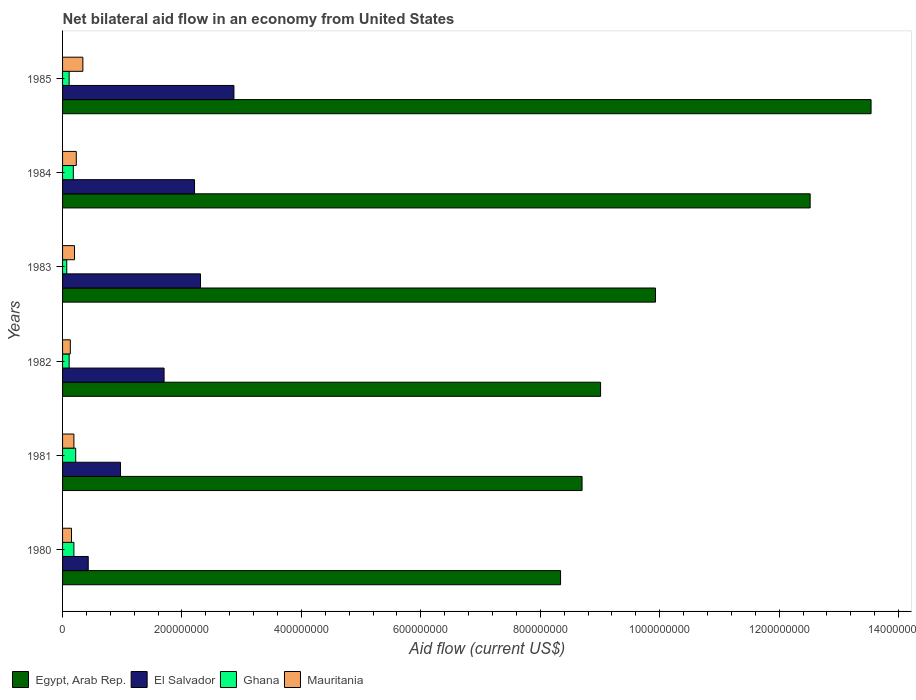Are the number of bars per tick equal to the number of legend labels?
Provide a succinct answer. Yes. Are the number of bars on each tick of the Y-axis equal?
Make the answer very short. Yes. How many bars are there on the 6th tick from the top?
Ensure brevity in your answer.  4. What is the label of the 1st group of bars from the top?
Your answer should be compact. 1985. In how many cases, is the number of bars for a given year not equal to the number of legend labels?
Your answer should be compact. 0. What is the net bilateral aid flow in Egypt, Arab Rep. in 1984?
Offer a very short reply. 1.25e+09. Across all years, what is the maximum net bilateral aid flow in Ghana?
Offer a very short reply. 2.20e+07. Across all years, what is the minimum net bilateral aid flow in Mauritania?
Keep it short and to the point. 1.30e+07. What is the total net bilateral aid flow in Mauritania in the graph?
Provide a succinct answer. 1.24e+08. What is the difference between the net bilateral aid flow in Egypt, Arab Rep. in 1982 and that in 1985?
Offer a terse response. -4.53e+08. What is the difference between the net bilateral aid flow in Egypt, Arab Rep. in 1985 and the net bilateral aid flow in Ghana in 1984?
Keep it short and to the point. 1.34e+09. What is the average net bilateral aid flow in El Salvador per year?
Make the answer very short. 1.75e+08. In the year 1985, what is the difference between the net bilateral aid flow in El Salvador and net bilateral aid flow in Egypt, Arab Rep.?
Keep it short and to the point. -1.07e+09. What is the ratio of the net bilateral aid flow in Egypt, Arab Rep. in 1980 to that in 1985?
Offer a terse response. 0.62. Is the net bilateral aid flow in Mauritania in 1980 less than that in 1981?
Ensure brevity in your answer.  Yes. Is the difference between the net bilateral aid flow in El Salvador in 1981 and 1983 greater than the difference between the net bilateral aid flow in Egypt, Arab Rep. in 1981 and 1983?
Your answer should be very brief. No. What is the difference between the highest and the second highest net bilateral aid flow in Egypt, Arab Rep.?
Provide a short and direct response. 1.02e+08. What is the difference between the highest and the lowest net bilateral aid flow in Egypt, Arab Rep.?
Ensure brevity in your answer.  5.20e+08. Is the sum of the net bilateral aid flow in Egypt, Arab Rep. in 1984 and 1985 greater than the maximum net bilateral aid flow in Ghana across all years?
Keep it short and to the point. Yes. What does the 1st bar from the top in 1984 represents?
Provide a short and direct response. Mauritania. What does the 1st bar from the bottom in 1985 represents?
Give a very brief answer. Egypt, Arab Rep. What is the difference between two consecutive major ticks on the X-axis?
Your answer should be very brief. 2.00e+08. Are the values on the major ticks of X-axis written in scientific E-notation?
Offer a very short reply. No. Does the graph contain any zero values?
Give a very brief answer. No. Where does the legend appear in the graph?
Your answer should be very brief. Bottom left. How many legend labels are there?
Offer a terse response. 4. What is the title of the graph?
Provide a succinct answer. Net bilateral aid flow in an economy from United States. Does "Italy" appear as one of the legend labels in the graph?
Offer a terse response. No. What is the Aid flow (current US$) of Egypt, Arab Rep. in 1980?
Provide a succinct answer. 8.34e+08. What is the Aid flow (current US$) of El Salvador in 1980?
Make the answer very short. 4.30e+07. What is the Aid flow (current US$) in Ghana in 1980?
Provide a succinct answer. 1.90e+07. What is the Aid flow (current US$) of Mauritania in 1980?
Keep it short and to the point. 1.50e+07. What is the Aid flow (current US$) in Egypt, Arab Rep. in 1981?
Give a very brief answer. 8.70e+08. What is the Aid flow (current US$) of El Salvador in 1981?
Ensure brevity in your answer.  9.70e+07. What is the Aid flow (current US$) in Ghana in 1981?
Make the answer very short. 2.20e+07. What is the Aid flow (current US$) of Mauritania in 1981?
Your answer should be very brief. 1.90e+07. What is the Aid flow (current US$) in Egypt, Arab Rep. in 1982?
Provide a short and direct response. 9.01e+08. What is the Aid flow (current US$) of El Salvador in 1982?
Make the answer very short. 1.70e+08. What is the Aid flow (current US$) in Ghana in 1982?
Your response must be concise. 1.10e+07. What is the Aid flow (current US$) of Mauritania in 1982?
Make the answer very short. 1.30e+07. What is the Aid flow (current US$) in Egypt, Arab Rep. in 1983?
Make the answer very short. 9.93e+08. What is the Aid flow (current US$) in El Salvador in 1983?
Ensure brevity in your answer.  2.31e+08. What is the Aid flow (current US$) in Mauritania in 1983?
Make the answer very short. 2.00e+07. What is the Aid flow (current US$) in Egypt, Arab Rep. in 1984?
Offer a terse response. 1.25e+09. What is the Aid flow (current US$) of El Salvador in 1984?
Offer a terse response. 2.21e+08. What is the Aid flow (current US$) of Ghana in 1984?
Ensure brevity in your answer.  1.80e+07. What is the Aid flow (current US$) of Mauritania in 1984?
Your answer should be very brief. 2.30e+07. What is the Aid flow (current US$) of Egypt, Arab Rep. in 1985?
Your answer should be very brief. 1.35e+09. What is the Aid flow (current US$) of El Salvador in 1985?
Keep it short and to the point. 2.87e+08. What is the Aid flow (current US$) in Ghana in 1985?
Offer a very short reply. 1.10e+07. What is the Aid flow (current US$) in Mauritania in 1985?
Your answer should be very brief. 3.40e+07. Across all years, what is the maximum Aid flow (current US$) of Egypt, Arab Rep.?
Give a very brief answer. 1.35e+09. Across all years, what is the maximum Aid flow (current US$) in El Salvador?
Offer a terse response. 2.87e+08. Across all years, what is the maximum Aid flow (current US$) of Ghana?
Make the answer very short. 2.20e+07. Across all years, what is the maximum Aid flow (current US$) in Mauritania?
Give a very brief answer. 3.40e+07. Across all years, what is the minimum Aid flow (current US$) of Egypt, Arab Rep.?
Your answer should be compact. 8.34e+08. Across all years, what is the minimum Aid flow (current US$) in El Salvador?
Your response must be concise. 4.30e+07. Across all years, what is the minimum Aid flow (current US$) in Mauritania?
Ensure brevity in your answer.  1.30e+07. What is the total Aid flow (current US$) in Egypt, Arab Rep. in the graph?
Keep it short and to the point. 6.20e+09. What is the total Aid flow (current US$) of El Salvador in the graph?
Offer a terse response. 1.05e+09. What is the total Aid flow (current US$) of Ghana in the graph?
Offer a terse response. 8.80e+07. What is the total Aid flow (current US$) in Mauritania in the graph?
Provide a succinct answer. 1.24e+08. What is the difference between the Aid flow (current US$) in Egypt, Arab Rep. in 1980 and that in 1981?
Offer a very short reply. -3.60e+07. What is the difference between the Aid flow (current US$) of El Salvador in 1980 and that in 1981?
Provide a succinct answer. -5.40e+07. What is the difference between the Aid flow (current US$) in Ghana in 1980 and that in 1981?
Provide a short and direct response. -3.00e+06. What is the difference between the Aid flow (current US$) in Egypt, Arab Rep. in 1980 and that in 1982?
Provide a short and direct response. -6.70e+07. What is the difference between the Aid flow (current US$) in El Salvador in 1980 and that in 1982?
Your answer should be compact. -1.27e+08. What is the difference between the Aid flow (current US$) in Ghana in 1980 and that in 1982?
Keep it short and to the point. 8.00e+06. What is the difference between the Aid flow (current US$) of Mauritania in 1980 and that in 1982?
Keep it short and to the point. 2.00e+06. What is the difference between the Aid flow (current US$) of Egypt, Arab Rep. in 1980 and that in 1983?
Your answer should be compact. -1.59e+08. What is the difference between the Aid flow (current US$) of El Salvador in 1980 and that in 1983?
Ensure brevity in your answer.  -1.88e+08. What is the difference between the Aid flow (current US$) of Ghana in 1980 and that in 1983?
Keep it short and to the point. 1.20e+07. What is the difference between the Aid flow (current US$) of Mauritania in 1980 and that in 1983?
Offer a terse response. -5.00e+06. What is the difference between the Aid flow (current US$) in Egypt, Arab Rep. in 1980 and that in 1984?
Give a very brief answer. -4.18e+08. What is the difference between the Aid flow (current US$) in El Salvador in 1980 and that in 1984?
Provide a succinct answer. -1.78e+08. What is the difference between the Aid flow (current US$) in Ghana in 1980 and that in 1984?
Your answer should be very brief. 1.00e+06. What is the difference between the Aid flow (current US$) of Mauritania in 1980 and that in 1984?
Provide a succinct answer. -8.00e+06. What is the difference between the Aid flow (current US$) in Egypt, Arab Rep. in 1980 and that in 1985?
Ensure brevity in your answer.  -5.20e+08. What is the difference between the Aid flow (current US$) of El Salvador in 1980 and that in 1985?
Offer a terse response. -2.44e+08. What is the difference between the Aid flow (current US$) of Mauritania in 1980 and that in 1985?
Your answer should be compact. -1.90e+07. What is the difference between the Aid flow (current US$) of Egypt, Arab Rep. in 1981 and that in 1982?
Give a very brief answer. -3.10e+07. What is the difference between the Aid flow (current US$) in El Salvador in 1981 and that in 1982?
Ensure brevity in your answer.  -7.30e+07. What is the difference between the Aid flow (current US$) in Ghana in 1981 and that in 1982?
Ensure brevity in your answer.  1.10e+07. What is the difference between the Aid flow (current US$) of Mauritania in 1981 and that in 1982?
Your answer should be very brief. 6.00e+06. What is the difference between the Aid flow (current US$) of Egypt, Arab Rep. in 1981 and that in 1983?
Give a very brief answer. -1.23e+08. What is the difference between the Aid flow (current US$) in El Salvador in 1981 and that in 1983?
Provide a succinct answer. -1.34e+08. What is the difference between the Aid flow (current US$) of Ghana in 1981 and that in 1983?
Make the answer very short. 1.50e+07. What is the difference between the Aid flow (current US$) in Egypt, Arab Rep. in 1981 and that in 1984?
Provide a short and direct response. -3.82e+08. What is the difference between the Aid flow (current US$) of El Salvador in 1981 and that in 1984?
Ensure brevity in your answer.  -1.24e+08. What is the difference between the Aid flow (current US$) of Ghana in 1981 and that in 1984?
Ensure brevity in your answer.  4.00e+06. What is the difference between the Aid flow (current US$) of Mauritania in 1981 and that in 1984?
Offer a very short reply. -4.00e+06. What is the difference between the Aid flow (current US$) in Egypt, Arab Rep. in 1981 and that in 1985?
Offer a terse response. -4.84e+08. What is the difference between the Aid flow (current US$) of El Salvador in 1981 and that in 1985?
Offer a very short reply. -1.90e+08. What is the difference between the Aid flow (current US$) of Ghana in 1981 and that in 1985?
Your answer should be compact. 1.10e+07. What is the difference between the Aid flow (current US$) of Mauritania in 1981 and that in 1985?
Your response must be concise. -1.50e+07. What is the difference between the Aid flow (current US$) of Egypt, Arab Rep. in 1982 and that in 1983?
Keep it short and to the point. -9.20e+07. What is the difference between the Aid flow (current US$) of El Salvador in 1982 and that in 1983?
Offer a very short reply. -6.10e+07. What is the difference between the Aid flow (current US$) in Ghana in 1982 and that in 1983?
Your response must be concise. 4.00e+06. What is the difference between the Aid flow (current US$) in Mauritania in 1982 and that in 1983?
Offer a very short reply. -7.00e+06. What is the difference between the Aid flow (current US$) of Egypt, Arab Rep. in 1982 and that in 1984?
Provide a short and direct response. -3.51e+08. What is the difference between the Aid flow (current US$) of El Salvador in 1982 and that in 1984?
Offer a very short reply. -5.10e+07. What is the difference between the Aid flow (current US$) in Ghana in 1982 and that in 1984?
Keep it short and to the point. -7.00e+06. What is the difference between the Aid flow (current US$) of Mauritania in 1982 and that in 1984?
Ensure brevity in your answer.  -1.00e+07. What is the difference between the Aid flow (current US$) of Egypt, Arab Rep. in 1982 and that in 1985?
Make the answer very short. -4.53e+08. What is the difference between the Aid flow (current US$) in El Salvador in 1982 and that in 1985?
Give a very brief answer. -1.17e+08. What is the difference between the Aid flow (current US$) of Mauritania in 1982 and that in 1985?
Give a very brief answer. -2.10e+07. What is the difference between the Aid flow (current US$) of Egypt, Arab Rep. in 1983 and that in 1984?
Your answer should be compact. -2.59e+08. What is the difference between the Aid flow (current US$) of Ghana in 1983 and that in 1984?
Give a very brief answer. -1.10e+07. What is the difference between the Aid flow (current US$) of Mauritania in 1983 and that in 1984?
Offer a very short reply. -3.00e+06. What is the difference between the Aid flow (current US$) of Egypt, Arab Rep. in 1983 and that in 1985?
Your answer should be very brief. -3.61e+08. What is the difference between the Aid flow (current US$) in El Salvador in 1983 and that in 1985?
Offer a terse response. -5.60e+07. What is the difference between the Aid flow (current US$) in Mauritania in 1983 and that in 1985?
Provide a succinct answer. -1.40e+07. What is the difference between the Aid flow (current US$) of Egypt, Arab Rep. in 1984 and that in 1985?
Your answer should be very brief. -1.02e+08. What is the difference between the Aid flow (current US$) of El Salvador in 1984 and that in 1985?
Your answer should be compact. -6.60e+07. What is the difference between the Aid flow (current US$) of Ghana in 1984 and that in 1985?
Offer a very short reply. 7.00e+06. What is the difference between the Aid flow (current US$) of Mauritania in 1984 and that in 1985?
Make the answer very short. -1.10e+07. What is the difference between the Aid flow (current US$) in Egypt, Arab Rep. in 1980 and the Aid flow (current US$) in El Salvador in 1981?
Your answer should be compact. 7.37e+08. What is the difference between the Aid flow (current US$) of Egypt, Arab Rep. in 1980 and the Aid flow (current US$) of Ghana in 1981?
Make the answer very short. 8.12e+08. What is the difference between the Aid flow (current US$) in Egypt, Arab Rep. in 1980 and the Aid flow (current US$) in Mauritania in 1981?
Your answer should be very brief. 8.15e+08. What is the difference between the Aid flow (current US$) in El Salvador in 1980 and the Aid flow (current US$) in Ghana in 1981?
Ensure brevity in your answer.  2.10e+07. What is the difference between the Aid flow (current US$) in El Salvador in 1980 and the Aid flow (current US$) in Mauritania in 1981?
Offer a terse response. 2.40e+07. What is the difference between the Aid flow (current US$) in Ghana in 1980 and the Aid flow (current US$) in Mauritania in 1981?
Offer a terse response. 0. What is the difference between the Aid flow (current US$) in Egypt, Arab Rep. in 1980 and the Aid flow (current US$) in El Salvador in 1982?
Your answer should be very brief. 6.64e+08. What is the difference between the Aid flow (current US$) of Egypt, Arab Rep. in 1980 and the Aid flow (current US$) of Ghana in 1982?
Provide a short and direct response. 8.23e+08. What is the difference between the Aid flow (current US$) of Egypt, Arab Rep. in 1980 and the Aid flow (current US$) of Mauritania in 1982?
Provide a succinct answer. 8.21e+08. What is the difference between the Aid flow (current US$) in El Salvador in 1980 and the Aid flow (current US$) in Ghana in 1982?
Make the answer very short. 3.20e+07. What is the difference between the Aid flow (current US$) in El Salvador in 1980 and the Aid flow (current US$) in Mauritania in 1982?
Give a very brief answer. 3.00e+07. What is the difference between the Aid flow (current US$) of Egypt, Arab Rep. in 1980 and the Aid flow (current US$) of El Salvador in 1983?
Offer a terse response. 6.03e+08. What is the difference between the Aid flow (current US$) of Egypt, Arab Rep. in 1980 and the Aid flow (current US$) of Ghana in 1983?
Make the answer very short. 8.27e+08. What is the difference between the Aid flow (current US$) of Egypt, Arab Rep. in 1980 and the Aid flow (current US$) of Mauritania in 1983?
Offer a very short reply. 8.14e+08. What is the difference between the Aid flow (current US$) in El Salvador in 1980 and the Aid flow (current US$) in Ghana in 1983?
Give a very brief answer. 3.60e+07. What is the difference between the Aid flow (current US$) in El Salvador in 1980 and the Aid flow (current US$) in Mauritania in 1983?
Your response must be concise. 2.30e+07. What is the difference between the Aid flow (current US$) of Egypt, Arab Rep. in 1980 and the Aid flow (current US$) of El Salvador in 1984?
Provide a short and direct response. 6.13e+08. What is the difference between the Aid flow (current US$) of Egypt, Arab Rep. in 1980 and the Aid flow (current US$) of Ghana in 1984?
Your answer should be very brief. 8.16e+08. What is the difference between the Aid flow (current US$) in Egypt, Arab Rep. in 1980 and the Aid flow (current US$) in Mauritania in 1984?
Give a very brief answer. 8.11e+08. What is the difference between the Aid flow (current US$) of El Salvador in 1980 and the Aid flow (current US$) of Ghana in 1984?
Give a very brief answer. 2.50e+07. What is the difference between the Aid flow (current US$) in Egypt, Arab Rep. in 1980 and the Aid flow (current US$) in El Salvador in 1985?
Keep it short and to the point. 5.47e+08. What is the difference between the Aid flow (current US$) of Egypt, Arab Rep. in 1980 and the Aid flow (current US$) of Ghana in 1985?
Offer a terse response. 8.23e+08. What is the difference between the Aid flow (current US$) of Egypt, Arab Rep. in 1980 and the Aid flow (current US$) of Mauritania in 1985?
Give a very brief answer. 8.00e+08. What is the difference between the Aid flow (current US$) of El Salvador in 1980 and the Aid flow (current US$) of Ghana in 1985?
Provide a succinct answer. 3.20e+07. What is the difference between the Aid flow (current US$) of El Salvador in 1980 and the Aid flow (current US$) of Mauritania in 1985?
Make the answer very short. 9.00e+06. What is the difference between the Aid flow (current US$) of Ghana in 1980 and the Aid flow (current US$) of Mauritania in 1985?
Your answer should be very brief. -1.50e+07. What is the difference between the Aid flow (current US$) in Egypt, Arab Rep. in 1981 and the Aid flow (current US$) in El Salvador in 1982?
Provide a succinct answer. 7.00e+08. What is the difference between the Aid flow (current US$) of Egypt, Arab Rep. in 1981 and the Aid flow (current US$) of Ghana in 1982?
Provide a short and direct response. 8.59e+08. What is the difference between the Aid flow (current US$) of Egypt, Arab Rep. in 1981 and the Aid flow (current US$) of Mauritania in 1982?
Make the answer very short. 8.57e+08. What is the difference between the Aid flow (current US$) in El Salvador in 1981 and the Aid flow (current US$) in Ghana in 1982?
Offer a very short reply. 8.60e+07. What is the difference between the Aid flow (current US$) in El Salvador in 1981 and the Aid flow (current US$) in Mauritania in 1982?
Offer a terse response. 8.40e+07. What is the difference between the Aid flow (current US$) of Ghana in 1981 and the Aid flow (current US$) of Mauritania in 1982?
Your response must be concise. 9.00e+06. What is the difference between the Aid flow (current US$) in Egypt, Arab Rep. in 1981 and the Aid flow (current US$) in El Salvador in 1983?
Provide a succinct answer. 6.39e+08. What is the difference between the Aid flow (current US$) of Egypt, Arab Rep. in 1981 and the Aid flow (current US$) of Ghana in 1983?
Your answer should be very brief. 8.63e+08. What is the difference between the Aid flow (current US$) in Egypt, Arab Rep. in 1981 and the Aid flow (current US$) in Mauritania in 1983?
Make the answer very short. 8.50e+08. What is the difference between the Aid flow (current US$) in El Salvador in 1981 and the Aid flow (current US$) in Ghana in 1983?
Give a very brief answer. 9.00e+07. What is the difference between the Aid flow (current US$) in El Salvador in 1981 and the Aid flow (current US$) in Mauritania in 1983?
Ensure brevity in your answer.  7.70e+07. What is the difference between the Aid flow (current US$) of Egypt, Arab Rep. in 1981 and the Aid flow (current US$) of El Salvador in 1984?
Offer a terse response. 6.49e+08. What is the difference between the Aid flow (current US$) in Egypt, Arab Rep. in 1981 and the Aid flow (current US$) in Ghana in 1984?
Your answer should be very brief. 8.52e+08. What is the difference between the Aid flow (current US$) in Egypt, Arab Rep. in 1981 and the Aid flow (current US$) in Mauritania in 1984?
Give a very brief answer. 8.47e+08. What is the difference between the Aid flow (current US$) of El Salvador in 1981 and the Aid flow (current US$) of Ghana in 1984?
Keep it short and to the point. 7.90e+07. What is the difference between the Aid flow (current US$) of El Salvador in 1981 and the Aid flow (current US$) of Mauritania in 1984?
Your response must be concise. 7.40e+07. What is the difference between the Aid flow (current US$) in Egypt, Arab Rep. in 1981 and the Aid flow (current US$) in El Salvador in 1985?
Provide a short and direct response. 5.83e+08. What is the difference between the Aid flow (current US$) of Egypt, Arab Rep. in 1981 and the Aid flow (current US$) of Ghana in 1985?
Your response must be concise. 8.59e+08. What is the difference between the Aid flow (current US$) in Egypt, Arab Rep. in 1981 and the Aid flow (current US$) in Mauritania in 1985?
Make the answer very short. 8.36e+08. What is the difference between the Aid flow (current US$) in El Salvador in 1981 and the Aid flow (current US$) in Ghana in 1985?
Give a very brief answer. 8.60e+07. What is the difference between the Aid flow (current US$) of El Salvador in 1981 and the Aid flow (current US$) of Mauritania in 1985?
Provide a short and direct response. 6.30e+07. What is the difference between the Aid flow (current US$) of Ghana in 1981 and the Aid flow (current US$) of Mauritania in 1985?
Keep it short and to the point. -1.20e+07. What is the difference between the Aid flow (current US$) in Egypt, Arab Rep. in 1982 and the Aid flow (current US$) in El Salvador in 1983?
Keep it short and to the point. 6.70e+08. What is the difference between the Aid flow (current US$) of Egypt, Arab Rep. in 1982 and the Aid flow (current US$) of Ghana in 1983?
Ensure brevity in your answer.  8.94e+08. What is the difference between the Aid flow (current US$) in Egypt, Arab Rep. in 1982 and the Aid flow (current US$) in Mauritania in 1983?
Your answer should be very brief. 8.81e+08. What is the difference between the Aid flow (current US$) in El Salvador in 1982 and the Aid flow (current US$) in Ghana in 1983?
Keep it short and to the point. 1.63e+08. What is the difference between the Aid flow (current US$) in El Salvador in 1982 and the Aid flow (current US$) in Mauritania in 1983?
Your answer should be compact. 1.50e+08. What is the difference between the Aid flow (current US$) of Ghana in 1982 and the Aid flow (current US$) of Mauritania in 1983?
Your answer should be very brief. -9.00e+06. What is the difference between the Aid flow (current US$) of Egypt, Arab Rep. in 1982 and the Aid flow (current US$) of El Salvador in 1984?
Give a very brief answer. 6.80e+08. What is the difference between the Aid flow (current US$) in Egypt, Arab Rep. in 1982 and the Aid flow (current US$) in Ghana in 1984?
Provide a short and direct response. 8.83e+08. What is the difference between the Aid flow (current US$) in Egypt, Arab Rep. in 1982 and the Aid flow (current US$) in Mauritania in 1984?
Your answer should be compact. 8.78e+08. What is the difference between the Aid flow (current US$) of El Salvador in 1982 and the Aid flow (current US$) of Ghana in 1984?
Offer a terse response. 1.52e+08. What is the difference between the Aid flow (current US$) in El Salvador in 1982 and the Aid flow (current US$) in Mauritania in 1984?
Your response must be concise. 1.47e+08. What is the difference between the Aid flow (current US$) in Ghana in 1982 and the Aid flow (current US$) in Mauritania in 1984?
Your response must be concise. -1.20e+07. What is the difference between the Aid flow (current US$) in Egypt, Arab Rep. in 1982 and the Aid flow (current US$) in El Salvador in 1985?
Make the answer very short. 6.14e+08. What is the difference between the Aid flow (current US$) of Egypt, Arab Rep. in 1982 and the Aid flow (current US$) of Ghana in 1985?
Your answer should be very brief. 8.90e+08. What is the difference between the Aid flow (current US$) in Egypt, Arab Rep. in 1982 and the Aid flow (current US$) in Mauritania in 1985?
Your answer should be very brief. 8.67e+08. What is the difference between the Aid flow (current US$) in El Salvador in 1982 and the Aid flow (current US$) in Ghana in 1985?
Offer a terse response. 1.59e+08. What is the difference between the Aid flow (current US$) of El Salvador in 1982 and the Aid flow (current US$) of Mauritania in 1985?
Your response must be concise. 1.36e+08. What is the difference between the Aid flow (current US$) of Ghana in 1982 and the Aid flow (current US$) of Mauritania in 1985?
Give a very brief answer. -2.30e+07. What is the difference between the Aid flow (current US$) of Egypt, Arab Rep. in 1983 and the Aid flow (current US$) of El Salvador in 1984?
Your response must be concise. 7.72e+08. What is the difference between the Aid flow (current US$) in Egypt, Arab Rep. in 1983 and the Aid flow (current US$) in Ghana in 1984?
Give a very brief answer. 9.75e+08. What is the difference between the Aid flow (current US$) of Egypt, Arab Rep. in 1983 and the Aid flow (current US$) of Mauritania in 1984?
Offer a terse response. 9.70e+08. What is the difference between the Aid flow (current US$) in El Salvador in 1983 and the Aid flow (current US$) in Ghana in 1984?
Your answer should be very brief. 2.13e+08. What is the difference between the Aid flow (current US$) in El Salvador in 1983 and the Aid flow (current US$) in Mauritania in 1984?
Make the answer very short. 2.08e+08. What is the difference between the Aid flow (current US$) of Ghana in 1983 and the Aid flow (current US$) of Mauritania in 1984?
Ensure brevity in your answer.  -1.60e+07. What is the difference between the Aid flow (current US$) of Egypt, Arab Rep. in 1983 and the Aid flow (current US$) of El Salvador in 1985?
Give a very brief answer. 7.06e+08. What is the difference between the Aid flow (current US$) in Egypt, Arab Rep. in 1983 and the Aid flow (current US$) in Ghana in 1985?
Your answer should be compact. 9.82e+08. What is the difference between the Aid flow (current US$) of Egypt, Arab Rep. in 1983 and the Aid flow (current US$) of Mauritania in 1985?
Make the answer very short. 9.59e+08. What is the difference between the Aid flow (current US$) of El Salvador in 1983 and the Aid flow (current US$) of Ghana in 1985?
Make the answer very short. 2.20e+08. What is the difference between the Aid flow (current US$) of El Salvador in 1983 and the Aid flow (current US$) of Mauritania in 1985?
Offer a very short reply. 1.97e+08. What is the difference between the Aid flow (current US$) of Ghana in 1983 and the Aid flow (current US$) of Mauritania in 1985?
Offer a very short reply. -2.70e+07. What is the difference between the Aid flow (current US$) of Egypt, Arab Rep. in 1984 and the Aid flow (current US$) of El Salvador in 1985?
Your response must be concise. 9.65e+08. What is the difference between the Aid flow (current US$) of Egypt, Arab Rep. in 1984 and the Aid flow (current US$) of Ghana in 1985?
Give a very brief answer. 1.24e+09. What is the difference between the Aid flow (current US$) of Egypt, Arab Rep. in 1984 and the Aid flow (current US$) of Mauritania in 1985?
Ensure brevity in your answer.  1.22e+09. What is the difference between the Aid flow (current US$) in El Salvador in 1984 and the Aid flow (current US$) in Ghana in 1985?
Offer a terse response. 2.10e+08. What is the difference between the Aid flow (current US$) of El Salvador in 1984 and the Aid flow (current US$) of Mauritania in 1985?
Offer a very short reply. 1.87e+08. What is the difference between the Aid flow (current US$) in Ghana in 1984 and the Aid flow (current US$) in Mauritania in 1985?
Offer a very short reply. -1.60e+07. What is the average Aid flow (current US$) in Egypt, Arab Rep. per year?
Offer a terse response. 1.03e+09. What is the average Aid flow (current US$) of El Salvador per year?
Offer a terse response. 1.75e+08. What is the average Aid flow (current US$) in Ghana per year?
Your response must be concise. 1.47e+07. What is the average Aid flow (current US$) in Mauritania per year?
Offer a very short reply. 2.07e+07. In the year 1980, what is the difference between the Aid flow (current US$) in Egypt, Arab Rep. and Aid flow (current US$) in El Salvador?
Offer a terse response. 7.91e+08. In the year 1980, what is the difference between the Aid flow (current US$) in Egypt, Arab Rep. and Aid flow (current US$) in Ghana?
Your answer should be very brief. 8.15e+08. In the year 1980, what is the difference between the Aid flow (current US$) of Egypt, Arab Rep. and Aid flow (current US$) of Mauritania?
Keep it short and to the point. 8.19e+08. In the year 1980, what is the difference between the Aid flow (current US$) in El Salvador and Aid flow (current US$) in Ghana?
Provide a short and direct response. 2.40e+07. In the year 1980, what is the difference between the Aid flow (current US$) of El Salvador and Aid flow (current US$) of Mauritania?
Your answer should be very brief. 2.80e+07. In the year 1980, what is the difference between the Aid flow (current US$) of Ghana and Aid flow (current US$) of Mauritania?
Offer a terse response. 4.00e+06. In the year 1981, what is the difference between the Aid flow (current US$) of Egypt, Arab Rep. and Aid flow (current US$) of El Salvador?
Your answer should be compact. 7.73e+08. In the year 1981, what is the difference between the Aid flow (current US$) of Egypt, Arab Rep. and Aid flow (current US$) of Ghana?
Your answer should be compact. 8.48e+08. In the year 1981, what is the difference between the Aid flow (current US$) in Egypt, Arab Rep. and Aid flow (current US$) in Mauritania?
Make the answer very short. 8.51e+08. In the year 1981, what is the difference between the Aid flow (current US$) of El Salvador and Aid flow (current US$) of Ghana?
Make the answer very short. 7.50e+07. In the year 1981, what is the difference between the Aid flow (current US$) in El Salvador and Aid flow (current US$) in Mauritania?
Offer a very short reply. 7.80e+07. In the year 1981, what is the difference between the Aid flow (current US$) of Ghana and Aid flow (current US$) of Mauritania?
Your answer should be very brief. 3.00e+06. In the year 1982, what is the difference between the Aid flow (current US$) of Egypt, Arab Rep. and Aid flow (current US$) of El Salvador?
Give a very brief answer. 7.31e+08. In the year 1982, what is the difference between the Aid flow (current US$) of Egypt, Arab Rep. and Aid flow (current US$) of Ghana?
Your answer should be very brief. 8.90e+08. In the year 1982, what is the difference between the Aid flow (current US$) in Egypt, Arab Rep. and Aid flow (current US$) in Mauritania?
Give a very brief answer. 8.88e+08. In the year 1982, what is the difference between the Aid flow (current US$) of El Salvador and Aid flow (current US$) of Ghana?
Offer a very short reply. 1.59e+08. In the year 1982, what is the difference between the Aid flow (current US$) in El Salvador and Aid flow (current US$) in Mauritania?
Provide a short and direct response. 1.57e+08. In the year 1983, what is the difference between the Aid flow (current US$) of Egypt, Arab Rep. and Aid flow (current US$) of El Salvador?
Ensure brevity in your answer.  7.62e+08. In the year 1983, what is the difference between the Aid flow (current US$) of Egypt, Arab Rep. and Aid flow (current US$) of Ghana?
Offer a very short reply. 9.86e+08. In the year 1983, what is the difference between the Aid flow (current US$) of Egypt, Arab Rep. and Aid flow (current US$) of Mauritania?
Keep it short and to the point. 9.73e+08. In the year 1983, what is the difference between the Aid flow (current US$) in El Salvador and Aid flow (current US$) in Ghana?
Provide a short and direct response. 2.24e+08. In the year 1983, what is the difference between the Aid flow (current US$) in El Salvador and Aid flow (current US$) in Mauritania?
Your answer should be very brief. 2.11e+08. In the year 1983, what is the difference between the Aid flow (current US$) of Ghana and Aid flow (current US$) of Mauritania?
Your answer should be very brief. -1.30e+07. In the year 1984, what is the difference between the Aid flow (current US$) of Egypt, Arab Rep. and Aid flow (current US$) of El Salvador?
Give a very brief answer. 1.03e+09. In the year 1984, what is the difference between the Aid flow (current US$) of Egypt, Arab Rep. and Aid flow (current US$) of Ghana?
Offer a terse response. 1.23e+09. In the year 1984, what is the difference between the Aid flow (current US$) of Egypt, Arab Rep. and Aid flow (current US$) of Mauritania?
Your answer should be compact. 1.23e+09. In the year 1984, what is the difference between the Aid flow (current US$) of El Salvador and Aid flow (current US$) of Ghana?
Ensure brevity in your answer.  2.03e+08. In the year 1984, what is the difference between the Aid flow (current US$) of El Salvador and Aid flow (current US$) of Mauritania?
Your answer should be compact. 1.98e+08. In the year 1984, what is the difference between the Aid flow (current US$) in Ghana and Aid flow (current US$) in Mauritania?
Your answer should be compact. -5.00e+06. In the year 1985, what is the difference between the Aid flow (current US$) in Egypt, Arab Rep. and Aid flow (current US$) in El Salvador?
Provide a succinct answer. 1.07e+09. In the year 1985, what is the difference between the Aid flow (current US$) in Egypt, Arab Rep. and Aid flow (current US$) in Ghana?
Your answer should be very brief. 1.34e+09. In the year 1985, what is the difference between the Aid flow (current US$) of Egypt, Arab Rep. and Aid flow (current US$) of Mauritania?
Make the answer very short. 1.32e+09. In the year 1985, what is the difference between the Aid flow (current US$) in El Salvador and Aid flow (current US$) in Ghana?
Your answer should be very brief. 2.76e+08. In the year 1985, what is the difference between the Aid flow (current US$) of El Salvador and Aid flow (current US$) of Mauritania?
Keep it short and to the point. 2.53e+08. In the year 1985, what is the difference between the Aid flow (current US$) of Ghana and Aid flow (current US$) of Mauritania?
Your response must be concise. -2.30e+07. What is the ratio of the Aid flow (current US$) of Egypt, Arab Rep. in 1980 to that in 1981?
Provide a short and direct response. 0.96. What is the ratio of the Aid flow (current US$) in El Salvador in 1980 to that in 1981?
Provide a short and direct response. 0.44. What is the ratio of the Aid flow (current US$) in Ghana in 1980 to that in 1981?
Your answer should be compact. 0.86. What is the ratio of the Aid flow (current US$) in Mauritania in 1980 to that in 1981?
Give a very brief answer. 0.79. What is the ratio of the Aid flow (current US$) in Egypt, Arab Rep. in 1980 to that in 1982?
Ensure brevity in your answer.  0.93. What is the ratio of the Aid flow (current US$) of El Salvador in 1980 to that in 1982?
Your answer should be very brief. 0.25. What is the ratio of the Aid flow (current US$) in Ghana in 1980 to that in 1982?
Your answer should be compact. 1.73. What is the ratio of the Aid flow (current US$) of Mauritania in 1980 to that in 1982?
Provide a succinct answer. 1.15. What is the ratio of the Aid flow (current US$) of Egypt, Arab Rep. in 1980 to that in 1983?
Your answer should be very brief. 0.84. What is the ratio of the Aid flow (current US$) of El Salvador in 1980 to that in 1983?
Your response must be concise. 0.19. What is the ratio of the Aid flow (current US$) in Ghana in 1980 to that in 1983?
Your answer should be compact. 2.71. What is the ratio of the Aid flow (current US$) in Mauritania in 1980 to that in 1983?
Keep it short and to the point. 0.75. What is the ratio of the Aid flow (current US$) of Egypt, Arab Rep. in 1980 to that in 1984?
Offer a terse response. 0.67. What is the ratio of the Aid flow (current US$) of El Salvador in 1980 to that in 1984?
Keep it short and to the point. 0.19. What is the ratio of the Aid flow (current US$) of Ghana in 1980 to that in 1984?
Your answer should be compact. 1.06. What is the ratio of the Aid flow (current US$) in Mauritania in 1980 to that in 1984?
Offer a very short reply. 0.65. What is the ratio of the Aid flow (current US$) in Egypt, Arab Rep. in 1980 to that in 1985?
Provide a succinct answer. 0.62. What is the ratio of the Aid flow (current US$) in El Salvador in 1980 to that in 1985?
Your response must be concise. 0.15. What is the ratio of the Aid flow (current US$) in Ghana in 1980 to that in 1985?
Your answer should be very brief. 1.73. What is the ratio of the Aid flow (current US$) in Mauritania in 1980 to that in 1985?
Provide a succinct answer. 0.44. What is the ratio of the Aid flow (current US$) of Egypt, Arab Rep. in 1981 to that in 1982?
Offer a very short reply. 0.97. What is the ratio of the Aid flow (current US$) in El Salvador in 1981 to that in 1982?
Offer a very short reply. 0.57. What is the ratio of the Aid flow (current US$) of Mauritania in 1981 to that in 1982?
Offer a very short reply. 1.46. What is the ratio of the Aid flow (current US$) in Egypt, Arab Rep. in 1981 to that in 1983?
Make the answer very short. 0.88. What is the ratio of the Aid flow (current US$) in El Salvador in 1981 to that in 1983?
Your response must be concise. 0.42. What is the ratio of the Aid flow (current US$) of Ghana in 1981 to that in 1983?
Provide a succinct answer. 3.14. What is the ratio of the Aid flow (current US$) in Mauritania in 1981 to that in 1983?
Provide a succinct answer. 0.95. What is the ratio of the Aid flow (current US$) of Egypt, Arab Rep. in 1981 to that in 1984?
Your answer should be compact. 0.69. What is the ratio of the Aid flow (current US$) in El Salvador in 1981 to that in 1984?
Give a very brief answer. 0.44. What is the ratio of the Aid flow (current US$) of Ghana in 1981 to that in 1984?
Ensure brevity in your answer.  1.22. What is the ratio of the Aid flow (current US$) of Mauritania in 1981 to that in 1984?
Offer a terse response. 0.83. What is the ratio of the Aid flow (current US$) of Egypt, Arab Rep. in 1981 to that in 1985?
Your answer should be very brief. 0.64. What is the ratio of the Aid flow (current US$) of El Salvador in 1981 to that in 1985?
Your answer should be very brief. 0.34. What is the ratio of the Aid flow (current US$) in Ghana in 1981 to that in 1985?
Offer a terse response. 2. What is the ratio of the Aid flow (current US$) in Mauritania in 1981 to that in 1985?
Ensure brevity in your answer.  0.56. What is the ratio of the Aid flow (current US$) in Egypt, Arab Rep. in 1982 to that in 1983?
Ensure brevity in your answer.  0.91. What is the ratio of the Aid flow (current US$) in El Salvador in 1982 to that in 1983?
Provide a succinct answer. 0.74. What is the ratio of the Aid flow (current US$) in Ghana in 1982 to that in 1983?
Provide a short and direct response. 1.57. What is the ratio of the Aid flow (current US$) in Mauritania in 1982 to that in 1983?
Provide a short and direct response. 0.65. What is the ratio of the Aid flow (current US$) of Egypt, Arab Rep. in 1982 to that in 1984?
Make the answer very short. 0.72. What is the ratio of the Aid flow (current US$) of El Salvador in 1982 to that in 1984?
Provide a short and direct response. 0.77. What is the ratio of the Aid flow (current US$) of Ghana in 1982 to that in 1984?
Offer a very short reply. 0.61. What is the ratio of the Aid flow (current US$) of Mauritania in 1982 to that in 1984?
Give a very brief answer. 0.57. What is the ratio of the Aid flow (current US$) in Egypt, Arab Rep. in 1982 to that in 1985?
Keep it short and to the point. 0.67. What is the ratio of the Aid flow (current US$) in El Salvador in 1982 to that in 1985?
Make the answer very short. 0.59. What is the ratio of the Aid flow (current US$) of Ghana in 1982 to that in 1985?
Give a very brief answer. 1. What is the ratio of the Aid flow (current US$) in Mauritania in 1982 to that in 1985?
Keep it short and to the point. 0.38. What is the ratio of the Aid flow (current US$) of Egypt, Arab Rep. in 1983 to that in 1984?
Keep it short and to the point. 0.79. What is the ratio of the Aid flow (current US$) in El Salvador in 1983 to that in 1984?
Offer a very short reply. 1.05. What is the ratio of the Aid flow (current US$) in Ghana in 1983 to that in 1984?
Provide a short and direct response. 0.39. What is the ratio of the Aid flow (current US$) of Mauritania in 1983 to that in 1984?
Offer a terse response. 0.87. What is the ratio of the Aid flow (current US$) of Egypt, Arab Rep. in 1983 to that in 1985?
Provide a succinct answer. 0.73. What is the ratio of the Aid flow (current US$) of El Salvador in 1983 to that in 1985?
Your response must be concise. 0.8. What is the ratio of the Aid flow (current US$) in Ghana in 1983 to that in 1985?
Offer a very short reply. 0.64. What is the ratio of the Aid flow (current US$) of Mauritania in 1983 to that in 1985?
Provide a short and direct response. 0.59. What is the ratio of the Aid flow (current US$) in Egypt, Arab Rep. in 1984 to that in 1985?
Your answer should be very brief. 0.92. What is the ratio of the Aid flow (current US$) of El Salvador in 1984 to that in 1985?
Provide a succinct answer. 0.77. What is the ratio of the Aid flow (current US$) in Ghana in 1984 to that in 1985?
Offer a terse response. 1.64. What is the ratio of the Aid flow (current US$) in Mauritania in 1984 to that in 1985?
Ensure brevity in your answer.  0.68. What is the difference between the highest and the second highest Aid flow (current US$) of Egypt, Arab Rep.?
Provide a short and direct response. 1.02e+08. What is the difference between the highest and the second highest Aid flow (current US$) of El Salvador?
Give a very brief answer. 5.60e+07. What is the difference between the highest and the second highest Aid flow (current US$) in Ghana?
Your response must be concise. 3.00e+06. What is the difference between the highest and the second highest Aid flow (current US$) in Mauritania?
Your response must be concise. 1.10e+07. What is the difference between the highest and the lowest Aid flow (current US$) of Egypt, Arab Rep.?
Offer a very short reply. 5.20e+08. What is the difference between the highest and the lowest Aid flow (current US$) of El Salvador?
Keep it short and to the point. 2.44e+08. What is the difference between the highest and the lowest Aid flow (current US$) of Ghana?
Provide a succinct answer. 1.50e+07. What is the difference between the highest and the lowest Aid flow (current US$) in Mauritania?
Provide a succinct answer. 2.10e+07. 